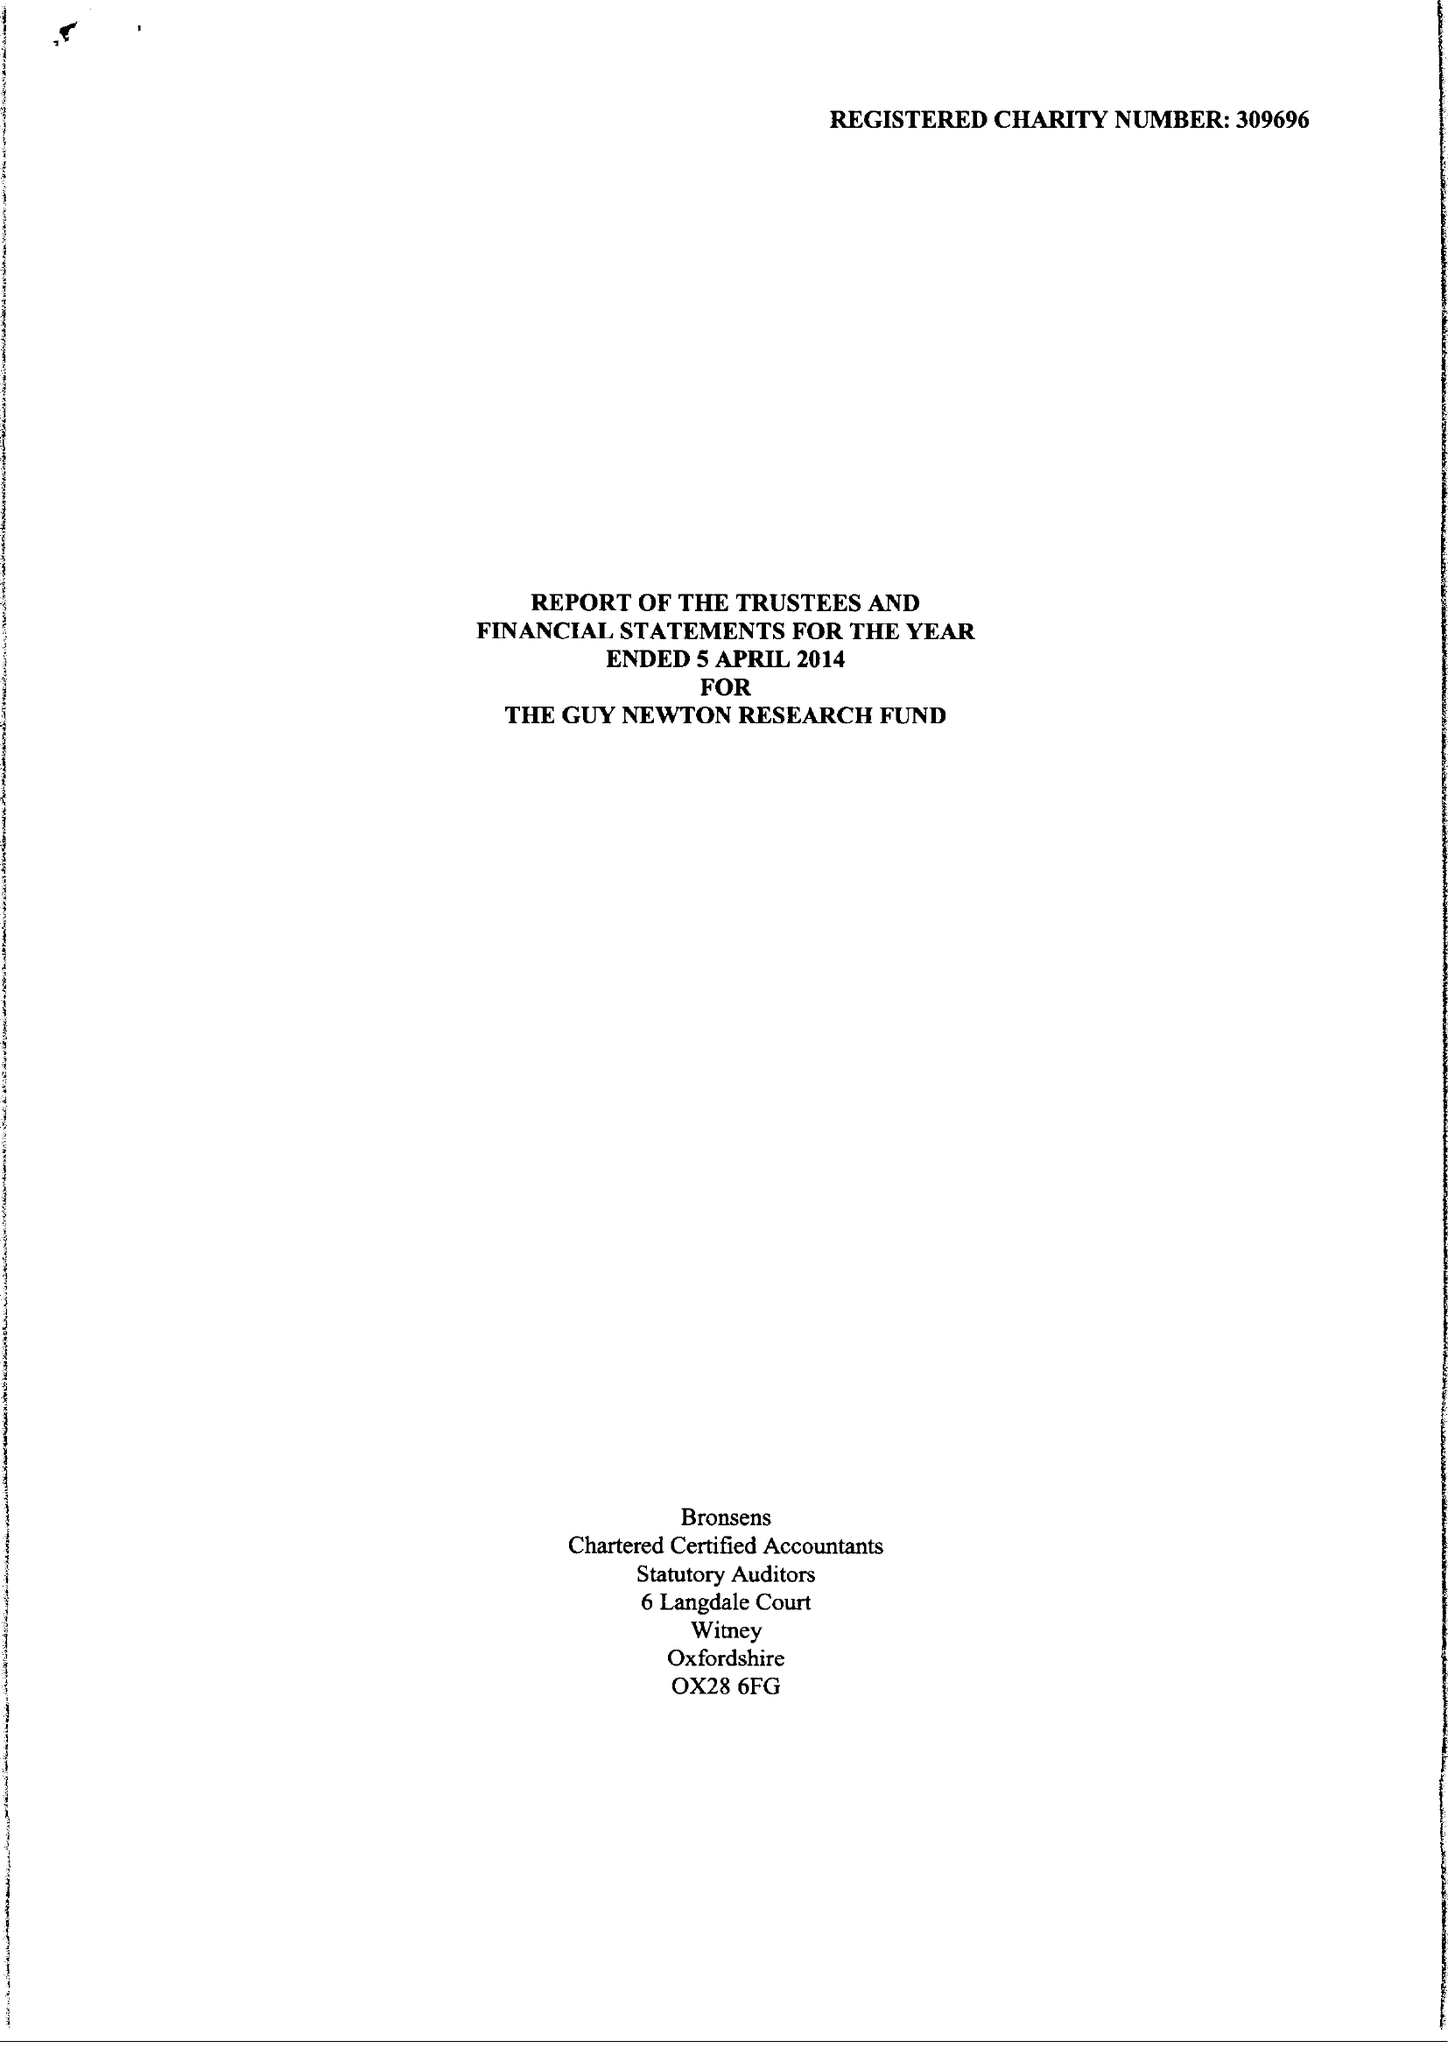What is the value for the report_date?
Answer the question using a single word or phrase. 2014-04-05 